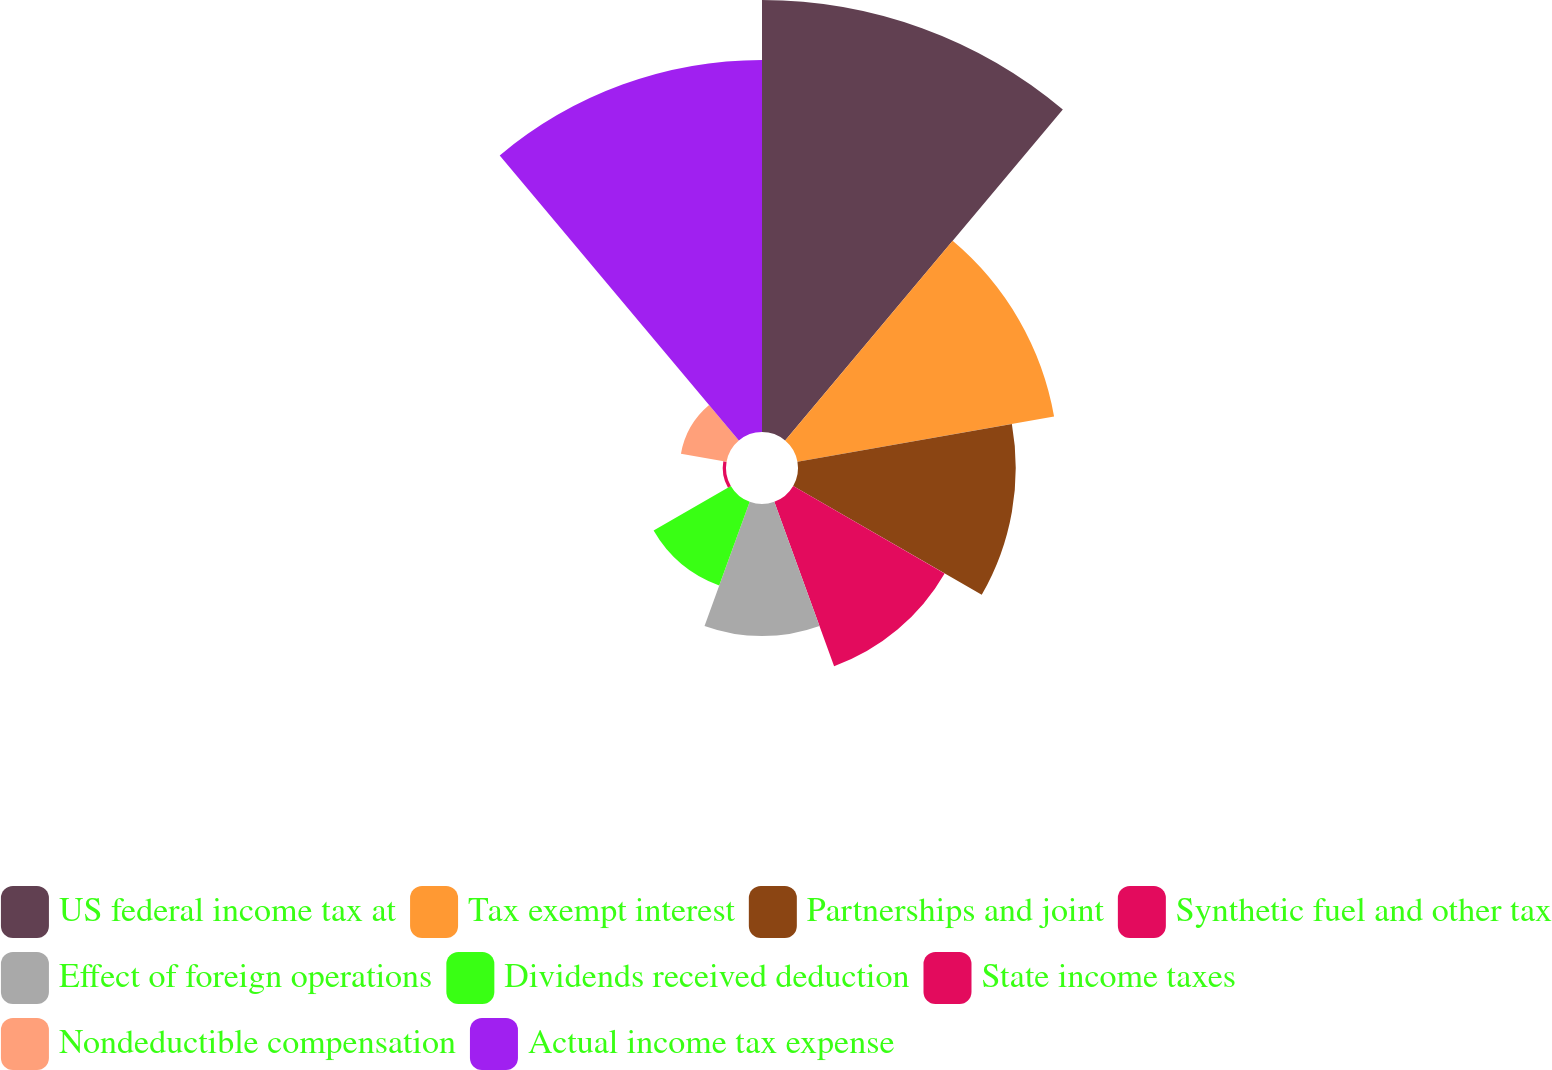Convert chart. <chart><loc_0><loc_0><loc_500><loc_500><pie_chart><fcel>US federal income tax at<fcel>Tax exempt interest<fcel>Partnerships and joint<fcel>Synthetic fuel and other tax<fcel>Effect of foreign operations<fcel>Dividends received deduction<fcel>State income taxes<fcel>Nondeductible compensation<fcel>Actual income tax expense<nl><fcel>25.0%<fcel>15.08%<fcel>12.6%<fcel>10.12%<fcel>7.64%<fcel>5.16%<fcel>0.19%<fcel>2.68%<fcel>21.53%<nl></chart> 